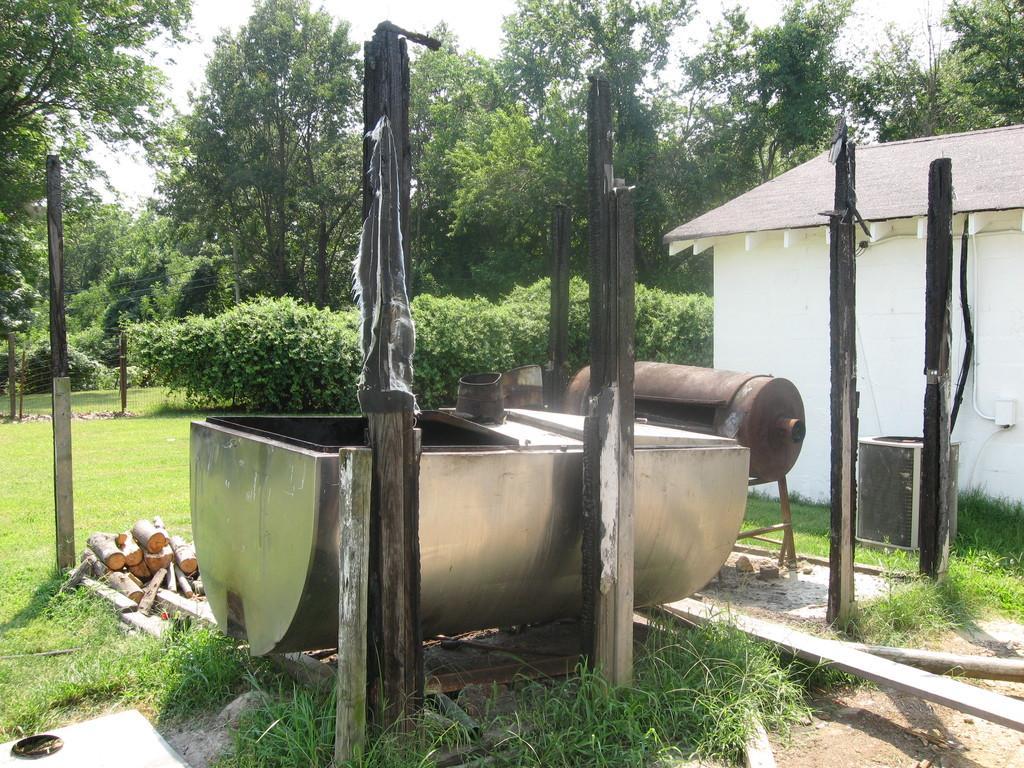Could you give a brief overview of what you see in this image? This picture is clicked outside. In the foreground we can see there are some objects placed on the ground and we can see the poles. On the right corner there is house and the plants. In the background there is a sky, trees and plants. 